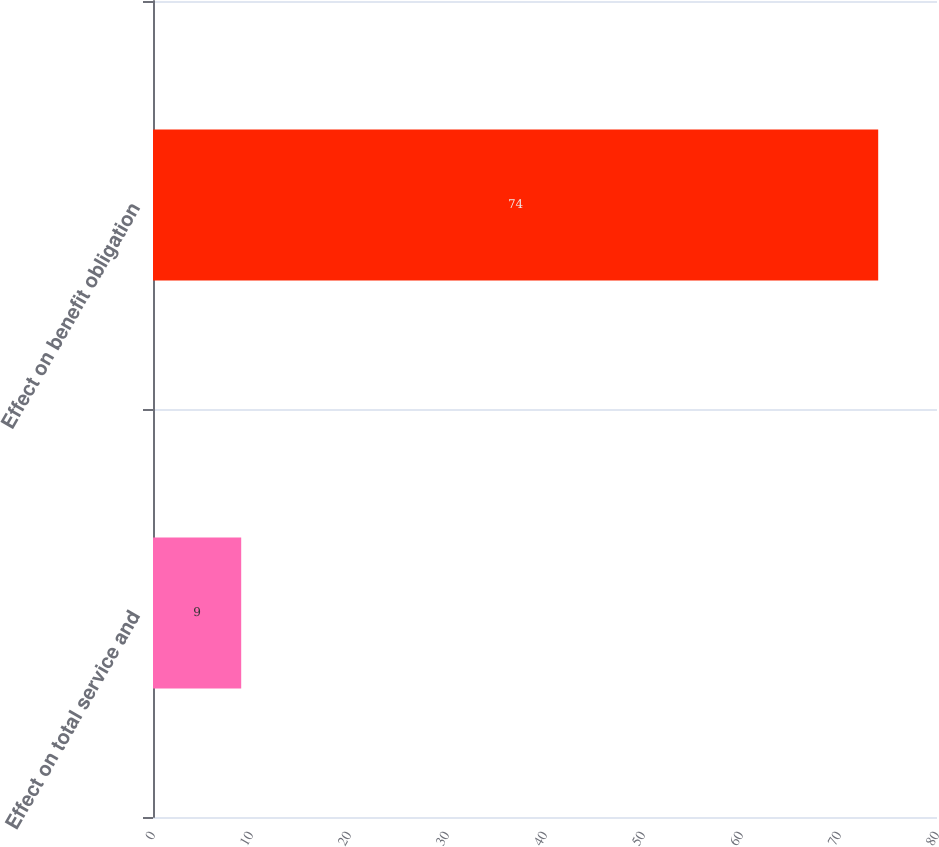<chart> <loc_0><loc_0><loc_500><loc_500><bar_chart><fcel>Effect on total service and<fcel>Effect on benefit obligation<nl><fcel>9<fcel>74<nl></chart> 